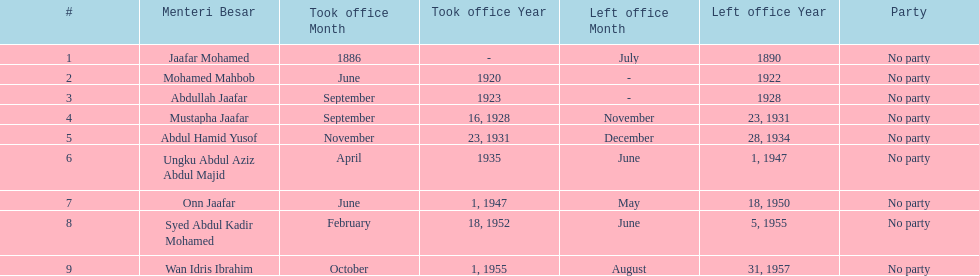Who spend the most amount of time in office? Ungku Abdul Aziz Abdul Majid. 